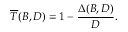Convert formula to latex. <formula><loc_0><loc_0><loc_500><loc_500>\overline { T } ( B , D ) = 1 - \frac { \Delta ( B , D ) } { D } .</formula> 